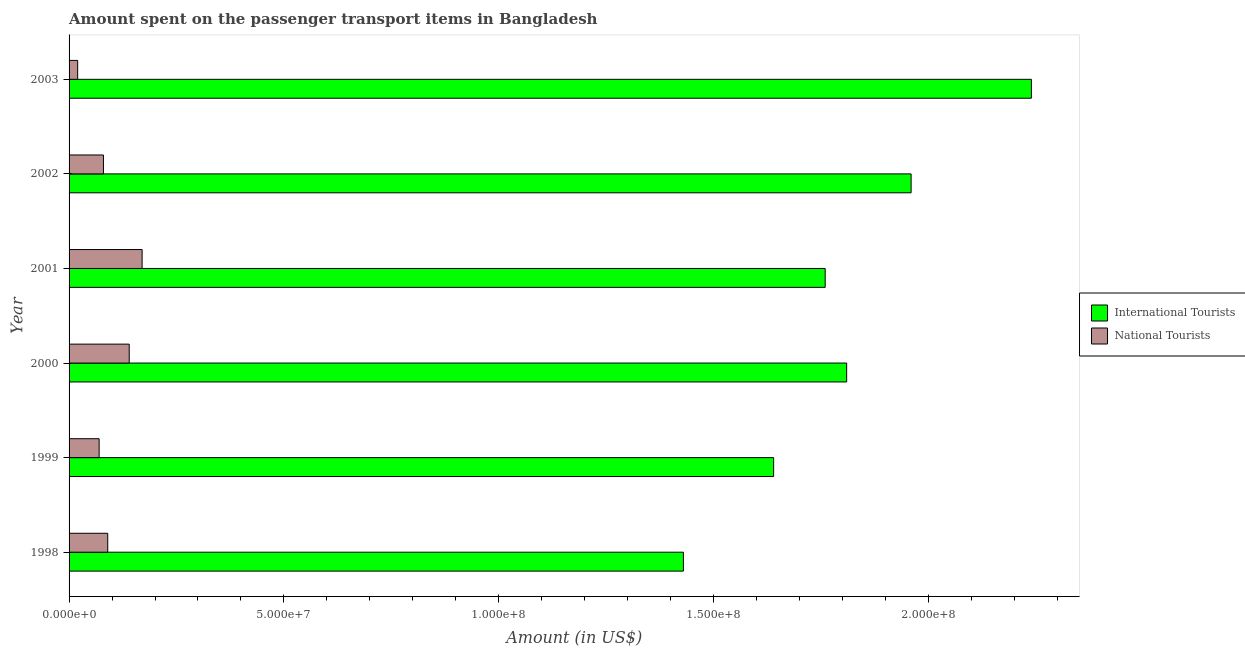How many different coloured bars are there?
Your answer should be compact. 2. Are the number of bars per tick equal to the number of legend labels?
Give a very brief answer. Yes. How many bars are there on the 6th tick from the top?
Make the answer very short. 2. How many bars are there on the 2nd tick from the bottom?
Your response must be concise. 2. What is the label of the 4th group of bars from the top?
Provide a short and direct response. 2000. What is the amount spent on transport items of national tourists in 2001?
Your response must be concise. 1.70e+07. Across all years, what is the maximum amount spent on transport items of international tourists?
Keep it short and to the point. 2.24e+08. Across all years, what is the minimum amount spent on transport items of national tourists?
Provide a short and direct response. 2.00e+06. In which year was the amount spent on transport items of national tourists minimum?
Your answer should be very brief. 2003. What is the total amount spent on transport items of national tourists in the graph?
Provide a short and direct response. 5.70e+07. What is the difference between the amount spent on transport items of international tourists in 1998 and that in 2001?
Ensure brevity in your answer.  -3.30e+07. What is the difference between the amount spent on transport items of international tourists in 2000 and the amount spent on transport items of national tourists in 2001?
Offer a very short reply. 1.64e+08. What is the average amount spent on transport items of national tourists per year?
Your answer should be very brief. 9.50e+06. In the year 1999, what is the difference between the amount spent on transport items of international tourists and amount spent on transport items of national tourists?
Your response must be concise. 1.57e+08. In how many years, is the amount spent on transport items of international tourists greater than 60000000 US$?
Provide a succinct answer. 6. What is the ratio of the amount spent on transport items of national tourists in 1998 to that in 2002?
Your answer should be very brief. 1.12. Is the difference between the amount spent on transport items of national tourists in 2000 and 2001 greater than the difference between the amount spent on transport items of international tourists in 2000 and 2001?
Give a very brief answer. No. What is the difference between the highest and the second highest amount spent on transport items of national tourists?
Provide a succinct answer. 3.00e+06. What is the difference between the highest and the lowest amount spent on transport items of national tourists?
Make the answer very short. 1.50e+07. In how many years, is the amount spent on transport items of international tourists greater than the average amount spent on transport items of international tourists taken over all years?
Keep it short and to the point. 3. Is the sum of the amount spent on transport items of international tourists in 1998 and 2002 greater than the maximum amount spent on transport items of national tourists across all years?
Your answer should be compact. Yes. What does the 1st bar from the top in 1999 represents?
Your answer should be very brief. National Tourists. What does the 2nd bar from the bottom in 2000 represents?
Give a very brief answer. National Tourists. What is the difference between two consecutive major ticks on the X-axis?
Keep it short and to the point. 5.00e+07. Where does the legend appear in the graph?
Your response must be concise. Center right. What is the title of the graph?
Provide a short and direct response. Amount spent on the passenger transport items in Bangladesh. What is the label or title of the X-axis?
Ensure brevity in your answer.  Amount (in US$). What is the label or title of the Y-axis?
Your answer should be very brief. Year. What is the Amount (in US$) in International Tourists in 1998?
Provide a succinct answer. 1.43e+08. What is the Amount (in US$) in National Tourists in 1998?
Offer a terse response. 9.00e+06. What is the Amount (in US$) in International Tourists in 1999?
Offer a terse response. 1.64e+08. What is the Amount (in US$) of National Tourists in 1999?
Your response must be concise. 7.00e+06. What is the Amount (in US$) of International Tourists in 2000?
Your response must be concise. 1.81e+08. What is the Amount (in US$) in National Tourists in 2000?
Make the answer very short. 1.40e+07. What is the Amount (in US$) of International Tourists in 2001?
Give a very brief answer. 1.76e+08. What is the Amount (in US$) of National Tourists in 2001?
Make the answer very short. 1.70e+07. What is the Amount (in US$) in International Tourists in 2002?
Offer a very short reply. 1.96e+08. What is the Amount (in US$) of National Tourists in 2002?
Provide a succinct answer. 8.00e+06. What is the Amount (in US$) of International Tourists in 2003?
Provide a short and direct response. 2.24e+08. What is the Amount (in US$) of National Tourists in 2003?
Keep it short and to the point. 2.00e+06. Across all years, what is the maximum Amount (in US$) in International Tourists?
Offer a very short reply. 2.24e+08. Across all years, what is the maximum Amount (in US$) in National Tourists?
Your answer should be very brief. 1.70e+07. Across all years, what is the minimum Amount (in US$) in International Tourists?
Give a very brief answer. 1.43e+08. Across all years, what is the minimum Amount (in US$) of National Tourists?
Offer a very short reply. 2.00e+06. What is the total Amount (in US$) in International Tourists in the graph?
Provide a succinct answer. 1.08e+09. What is the total Amount (in US$) in National Tourists in the graph?
Your answer should be compact. 5.70e+07. What is the difference between the Amount (in US$) of International Tourists in 1998 and that in 1999?
Offer a terse response. -2.10e+07. What is the difference between the Amount (in US$) in National Tourists in 1998 and that in 1999?
Offer a terse response. 2.00e+06. What is the difference between the Amount (in US$) of International Tourists in 1998 and that in 2000?
Offer a terse response. -3.80e+07. What is the difference between the Amount (in US$) in National Tourists in 1998 and that in 2000?
Offer a terse response. -5.00e+06. What is the difference between the Amount (in US$) in International Tourists in 1998 and that in 2001?
Keep it short and to the point. -3.30e+07. What is the difference between the Amount (in US$) in National Tourists in 1998 and that in 2001?
Provide a succinct answer. -8.00e+06. What is the difference between the Amount (in US$) in International Tourists in 1998 and that in 2002?
Your response must be concise. -5.30e+07. What is the difference between the Amount (in US$) in National Tourists in 1998 and that in 2002?
Your response must be concise. 1.00e+06. What is the difference between the Amount (in US$) in International Tourists in 1998 and that in 2003?
Keep it short and to the point. -8.10e+07. What is the difference between the Amount (in US$) of International Tourists in 1999 and that in 2000?
Make the answer very short. -1.70e+07. What is the difference between the Amount (in US$) of National Tourists in 1999 and that in 2000?
Provide a succinct answer. -7.00e+06. What is the difference between the Amount (in US$) in International Tourists in 1999 and that in 2001?
Offer a very short reply. -1.20e+07. What is the difference between the Amount (in US$) of National Tourists in 1999 and that in 2001?
Provide a short and direct response. -1.00e+07. What is the difference between the Amount (in US$) of International Tourists in 1999 and that in 2002?
Your response must be concise. -3.20e+07. What is the difference between the Amount (in US$) of International Tourists in 1999 and that in 2003?
Your answer should be very brief. -6.00e+07. What is the difference between the Amount (in US$) in International Tourists in 2000 and that in 2001?
Your answer should be very brief. 5.00e+06. What is the difference between the Amount (in US$) of National Tourists in 2000 and that in 2001?
Provide a succinct answer. -3.00e+06. What is the difference between the Amount (in US$) in International Tourists in 2000 and that in 2002?
Offer a terse response. -1.50e+07. What is the difference between the Amount (in US$) of National Tourists in 2000 and that in 2002?
Your answer should be very brief. 6.00e+06. What is the difference between the Amount (in US$) in International Tourists in 2000 and that in 2003?
Ensure brevity in your answer.  -4.30e+07. What is the difference between the Amount (in US$) of National Tourists in 2000 and that in 2003?
Offer a terse response. 1.20e+07. What is the difference between the Amount (in US$) of International Tourists in 2001 and that in 2002?
Your answer should be compact. -2.00e+07. What is the difference between the Amount (in US$) in National Tourists in 2001 and that in 2002?
Your answer should be very brief. 9.00e+06. What is the difference between the Amount (in US$) in International Tourists in 2001 and that in 2003?
Offer a very short reply. -4.80e+07. What is the difference between the Amount (in US$) in National Tourists in 2001 and that in 2003?
Your answer should be compact. 1.50e+07. What is the difference between the Amount (in US$) of International Tourists in 2002 and that in 2003?
Your answer should be compact. -2.80e+07. What is the difference between the Amount (in US$) in International Tourists in 1998 and the Amount (in US$) in National Tourists in 1999?
Make the answer very short. 1.36e+08. What is the difference between the Amount (in US$) of International Tourists in 1998 and the Amount (in US$) of National Tourists in 2000?
Your response must be concise. 1.29e+08. What is the difference between the Amount (in US$) in International Tourists in 1998 and the Amount (in US$) in National Tourists in 2001?
Keep it short and to the point. 1.26e+08. What is the difference between the Amount (in US$) in International Tourists in 1998 and the Amount (in US$) in National Tourists in 2002?
Your answer should be very brief. 1.35e+08. What is the difference between the Amount (in US$) of International Tourists in 1998 and the Amount (in US$) of National Tourists in 2003?
Make the answer very short. 1.41e+08. What is the difference between the Amount (in US$) in International Tourists in 1999 and the Amount (in US$) in National Tourists in 2000?
Ensure brevity in your answer.  1.50e+08. What is the difference between the Amount (in US$) of International Tourists in 1999 and the Amount (in US$) of National Tourists in 2001?
Your answer should be compact. 1.47e+08. What is the difference between the Amount (in US$) of International Tourists in 1999 and the Amount (in US$) of National Tourists in 2002?
Make the answer very short. 1.56e+08. What is the difference between the Amount (in US$) of International Tourists in 1999 and the Amount (in US$) of National Tourists in 2003?
Provide a short and direct response. 1.62e+08. What is the difference between the Amount (in US$) of International Tourists in 2000 and the Amount (in US$) of National Tourists in 2001?
Your response must be concise. 1.64e+08. What is the difference between the Amount (in US$) of International Tourists in 2000 and the Amount (in US$) of National Tourists in 2002?
Offer a very short reply. 1.73e+08. What is the difference between the Amount (in US$) of International Tourists in 2000 and the Amount (in US$) of National Tourists in 2003?
Make the answer very short. 1.79e+08. What is the difference between the Amount (in US$) in International Tourists in 2001 and the Amount (in US$) in National Tourists in 2002?
Your answer should be very brief. 1.68e+08. What is the difference between the Amount (in US$) in International Tourists in 2001 and the Amount (in US$) in National Tourists in 2003?
Provide a short and direct response. 1.74e+08. What is the difference between the Amount (in US$) of International Tourists in 2002 and the Amount (in US$) of National Tourists in 2003?
Offer a very short reply. 1.94e+08. What is the average Amount (in US$) in International Tourists per year?
Provide a short and direct response. 1.81e+08. What is the average Amount (in US$) in National Tourists per year?
Ensure brevity in your answer.  9.50e+06. In the year 1998, what is the difference between the Amount (in US$) of International Tourists and Amount (in US$) of National Tourists?
Your response must be concise. 1.34e+08. In the year 1999, what is the difference between the Amount (in US$) of International Tourists and Amount (in US$) of National Tourists?
Keep it short and to the point. 1.57e+08. In the year 2000, what is the difference between the Amount (in US$) of International Tourists and Amount (in US$) of National Tourists?
Your response must be concise. 1.67e+08. In the year 2001, what is the difference between the Amount (in US$) in International Tourists and Amount (in US$) in National Tourists?
Give a very brief answer. 1.59e+08. In the year 2002, what is the difference between the Amount (in US$) in International Tourists and Amount (in US$) in National Tourists?
Keep it short and to the point. 1.88e+08. In the year 2003, what is the difference between the Amount (in US$) of International Tourists and Amount (in US$) of National Tourists?
Keep it short and to the point. 2.22e+08. What is the ratio of the Amount (in US$) in International Tourists in 1998 to that in 1999?
Your answer should be very brief. 0.87. What is the ratio of the Amount (in US$) of International Tourists in 1998 to that in 2000?
Provide a short and direct response. 0.79. What is the ratio of the Amount (in US$) of National Tourists in 1998 to that in 2000?
Provide a succinct answer. 0.64. What is the ratio of the Amount (in US$) in International Tourists in 1998 to that in 2001?
Provide a short and direct response. 0.81. What is the ratio of the Amount (in US$) in National Tourists in 1998 to that in 2001?
Offer a terse response. 0.53. What is the ratio of the Amount (in US$) in International Tourists in 1998 to that in 2002?
Your answer should be compact. 0.73. What is the ratio of the Amount (in US$) in International Tourists in 1998 to that in 2003?
Your response must be concise. 0.64. What is the ratio of the Amount (in US$) in International Tourists in 1999 to that in 2000?
Your response must be concise. 0.91. What is the ratio of the Amount (in US$) of National Tourists in 1999 to that in 2000?
Make the answer very short. 0.5. What is the ratio of the Amount (in US$) of International Tourists in 1999 to that in 2001?
Provide a succinct answer. 0.93. What is the ratio of the Amount (in US$) of National Tourists in 1999 to that in 2001?
Give a very brief answer. 0.41. What is the ratio of the Amount (in US$) of International Tourists in 1999 to that in 2002?
Provide a short and direct response. 0.84. What is the ratio of the Amount (in US$) in International Tourists in 1999 to that in 2003?
Make the answer very short. 0.73. What is the ratio of the Amount (in US$) in National Tourists in 1999 to that in 2003?
Offer a terse response. 3.5. What is the ratio of the Amount (in US$) of International Tourists in 2000 to that in 2001?
Your answer should be compact. 1.03. What is the ratio of the Amount (in US$) in National Tourists in 2000 to that in 2001?
Provide a short and direct response. 0.82. What is the ratio of the Amount (in US$) of International Tourists in 2000 to that in 2002?
Your response must be concise. 0.92. What is the ratio of the Amount (in US$) of International Tourists in 2000 to that in 2003?
Offer a terse response. 0.81. What is the ratio of the Amount (in US$) in International Tourists in 2001 to that in 2002?
Make the answer very short. 0.9. What is the ratio of the Amount (in US$) in National Tourists in 2001 to that in 2002?
Keep it short and to the point. 2.12. What is the ratio of the Amount (in US$) in International Tourists in 2001 to that in 2003?
Provide a short and direct response. 0.79. What is the ratio of the Amount (in US$) in International Tourists in 2002 to that in 2003?
Ensure brevity in your answer.  0.88. What is the ratio of the Amount (in US$) of National Tourists in 2002 to that in 2003?
Your response must be concise. 4. What is the difference between the highest and the second highest Amount (in US$) in International Tourists?
Your answer should be compact. 2.80e+07. What is the difference between the highest and the lowest Amount (in US$) of International Tourists?
Your response must be concise. 8.10e+07. What is the difference between the highest and the lowest Amount (in US$) of National Tourists?
Offer a terse response. 1.50e+07. 